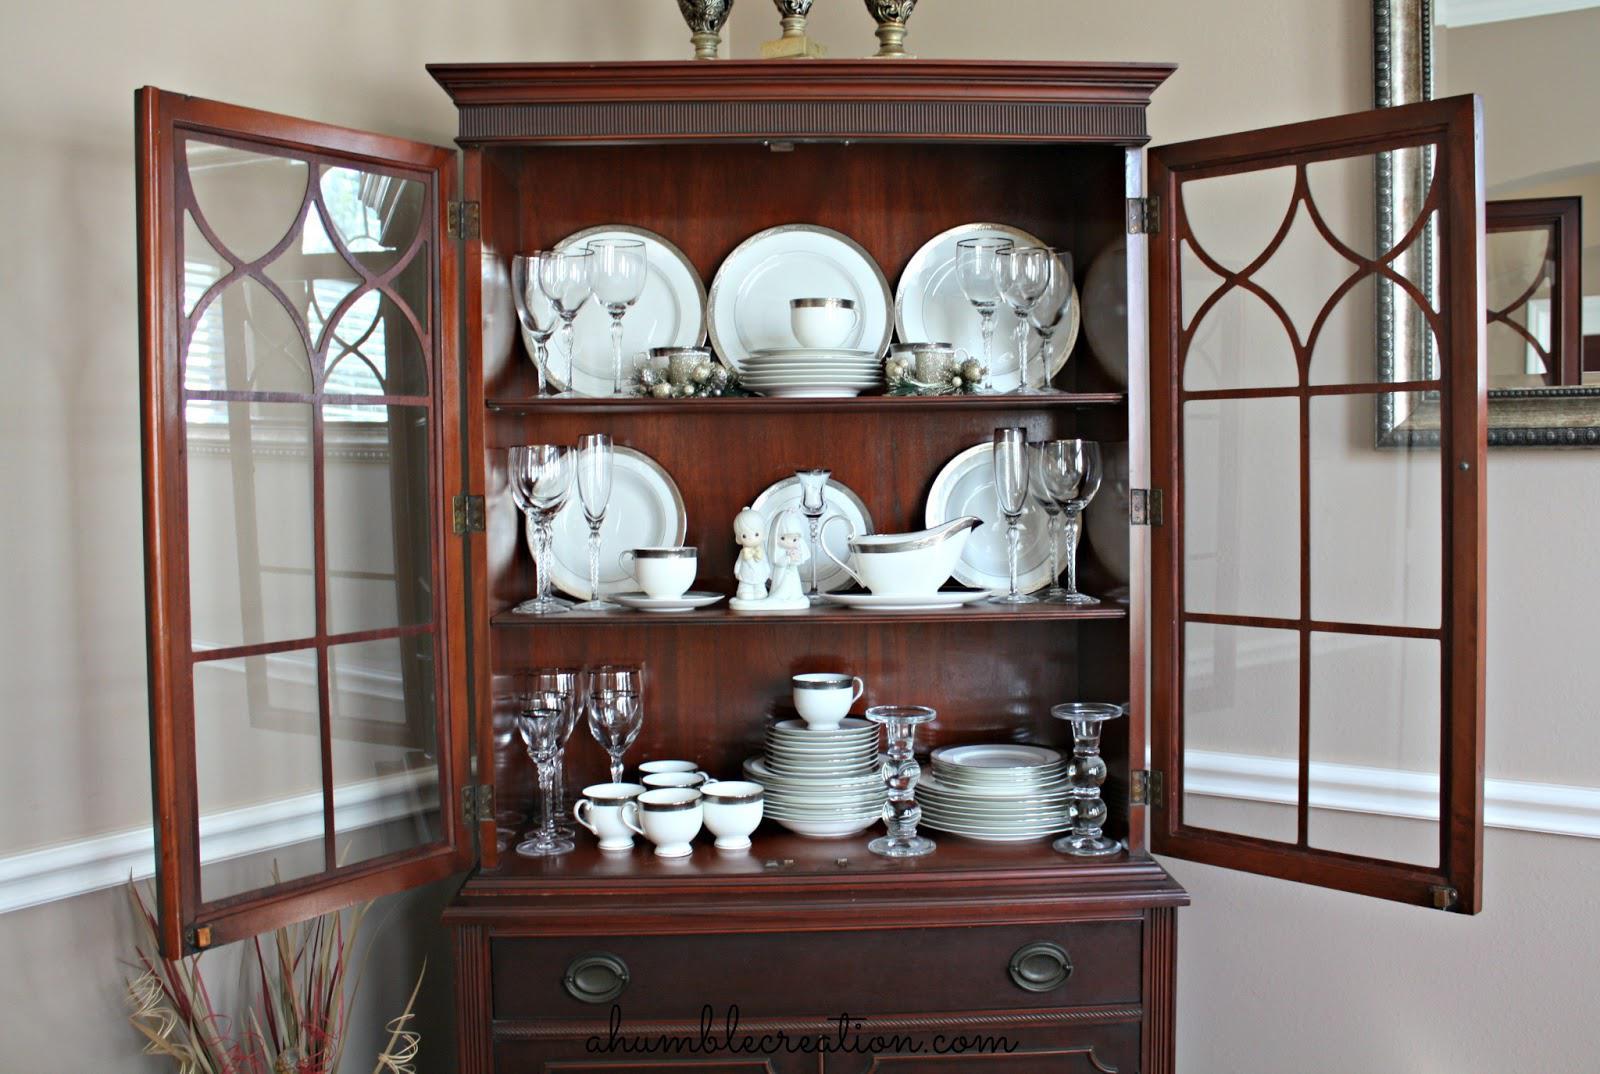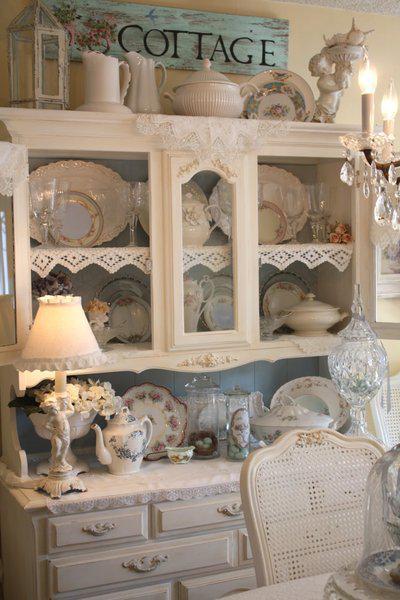The first image is the image on the left, the second image is the image on the right. For the images shown, is this caption "An image shows a brown cabinet with an arched top and open doors." true? Answer yes or no. No. The first image is the image on the left, the second image is the image on the right. Evaluate the accuracy of this statement regarding the images: "One of the cabinets containing dishes is brown.". Is it true? Answer yes or no. Yes. 